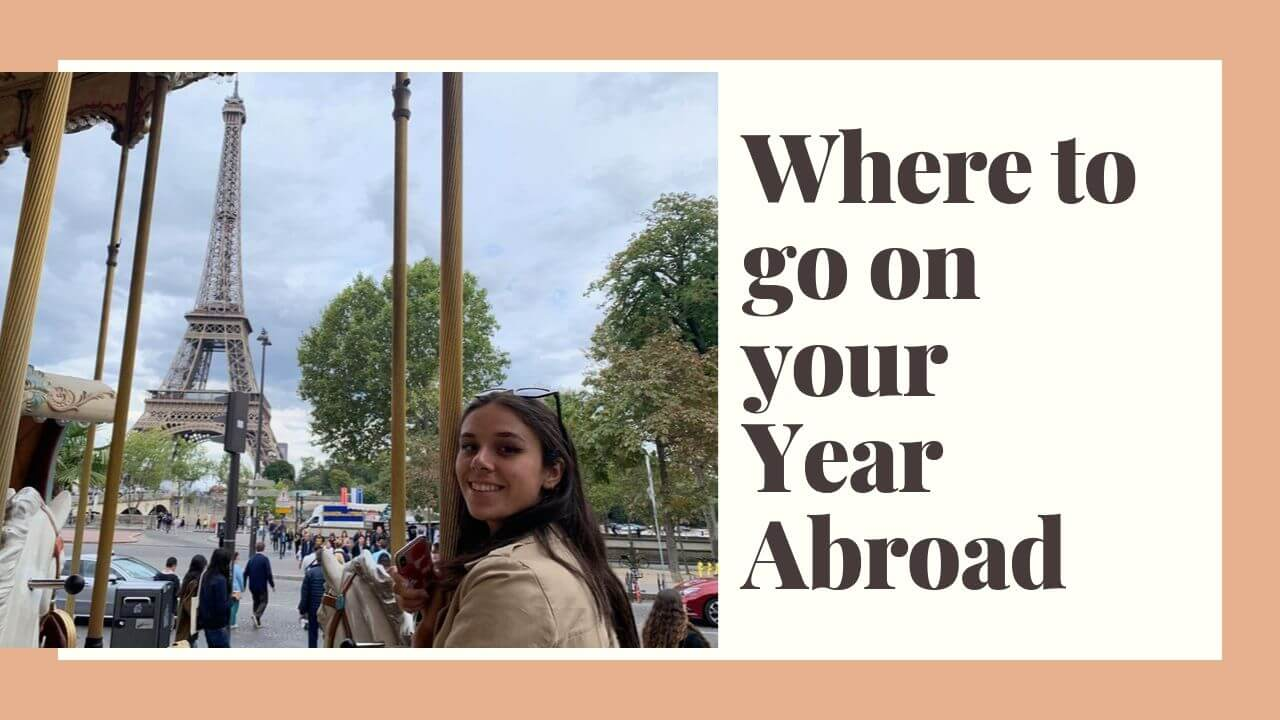Considering the design of the graphic, what target audience might the message be intended for? The design of the graphic, featuring the iconic Eiffel Tower and the text 'Where to go on your Year Abroad,' strongly suggests that it is targeting students or young adults who are planning international travel or study programs. The phrase 'Year Abroad' commonly refers to educational experiences such as study abroad programs or gap years. The vibrant and lively image of the woman enjoying a carousel ride adds a sense of adventure and excitement, appealing to a younger demographic eager for unique and enriching travel experiences during their academic or personal development journeys. 